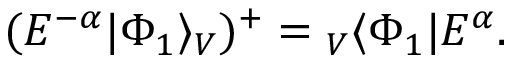<formula> <loc_0><loc_0><loc_500><loc_500>( E ^ { - \alpha } | \Phi _ { 1 } \rangle _ { V } ) ^ { + } _ { V } \langle \Phi _ { 1 } | E ^ { \alpha } .</formula> 